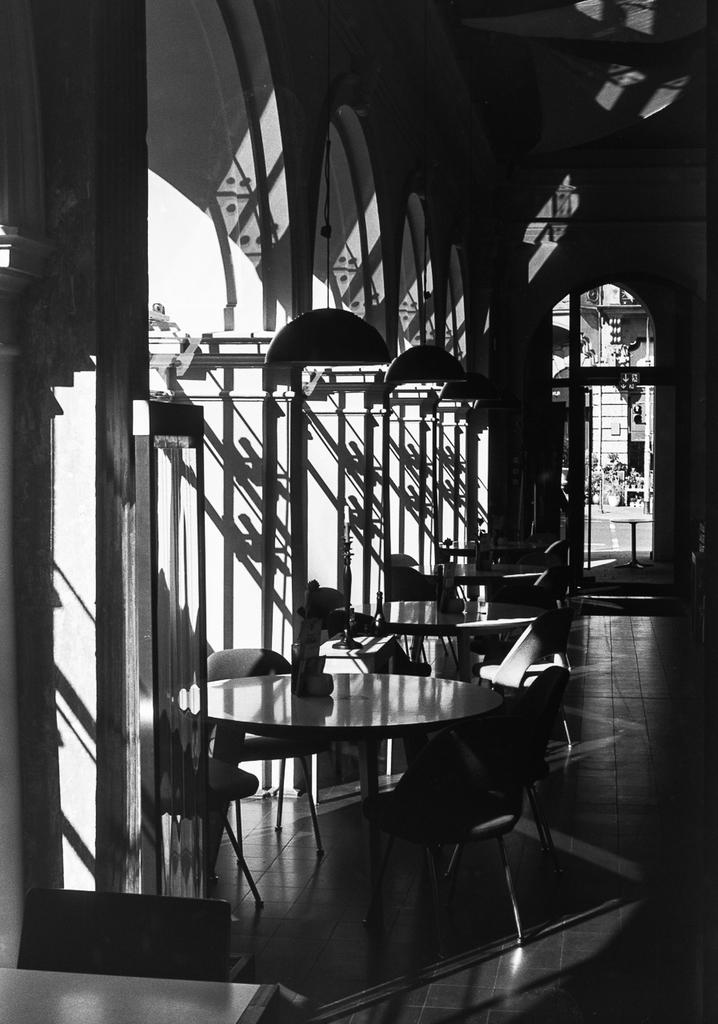What is on the ground in the image? There is a table on the ground in the image. What type of vehicles can be seen in the image? There are cars in the image. What architectural features are present in the image? There are pillars in the image. Can you describe the lighting conditions in the image? The image appears to be in a dark environment. What type of fruit is hanging from the pillars in the image? There is no fruit present in the image; it only features a table, cars, and pillars. 